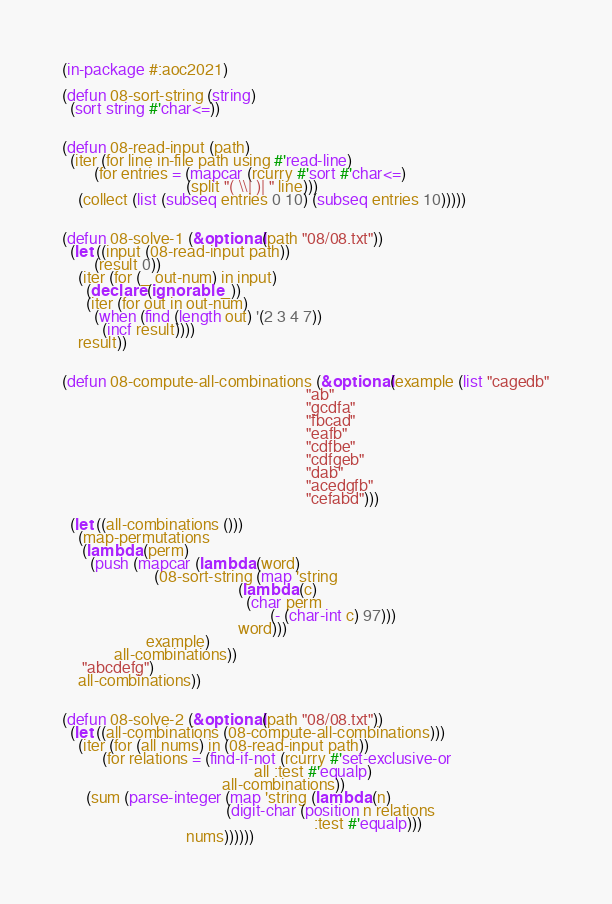Convert code to text. <code><loc_0><loc_0><loc_500><loc_500><_Lisp_>(in-package #:aoc2021)

(defun 08-sort-string (string)
  (sort string #'char<=))


(defun 08-read-input (path)
  (iter (for line in-file path using #'read-line)
        (for entries = (mapcar (rcurry #'sort #'char<=)
                               (split "( \\| )| " line)))
    (collect (list (subseq entries 0 10) (subseq entries 10)))))


(defun 08-solve-1 (&optional (path "08/08.txt"))
  (let ((input (08-read-input path))
        (result 0))
    (iter (for (_ out-num) in input)
      (declare (ignorable _))
      (iter (for out in out-num)
        (when (find (length out) '(2 3 4 7))
          (incf result))))
    result))


(defun 08-compute-all-combinations (&optional (example (list "cagedb"
                                                             "ab"
                                                             "gcdfa"
                                                             "fbcad"
                                                             "eafb"
                                                             "cdfbe"
                                                             "cdfgeb"
                                                             "dab"
                                                             "acedgfb"
                                                             "cefabd")))

  (let ((all-combinations ()))
    (map-permutations
     (lambda (perm)
       (push (mapcar (lambda (word)
                       (08-sort-string (map 'string
                                            (lambda (c)
                                              (char perm
                                                    (- (char-int c) 97)))
                                            word)))
                     example)
             all-combinations))
     "abcdefg")
    all-combinations))


(defun 08-solve-2 (&optional (path "08/08.txt"))
  (let ((all-combinations (08-compute-all-combinations)))
    (iter (for (all nums) in (08-read-input path))
          (for relations = (find-if-not (rcurry #'set-exclusive-or
                                                all :test #'equalp)
                                        all-combinations))
      (sum (parse-integer (map 'string (lambda (n)
                                         (digit-char (position n relations
                                                               :test #'equalp)))
                               nums))))))
</code> 